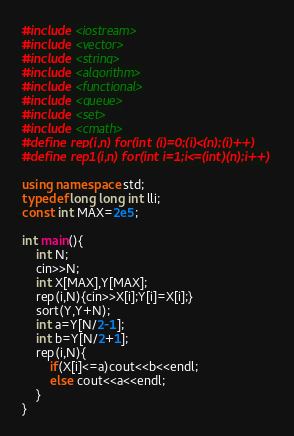Convert code to text. <code><loc_0><loc_0><loc_500><loc_500><_C++_>#include <iostream>
#include <vector>
#include <string>
#include <algorithm>
#include <functional>
#include <queue>
#include <set>
#include <cmath>
#define rep(i,n) for(int (i)=0;(i)<(n);(i)++)
#define rep1(i,n) for(int i=1;i<=(int)(n);i++)

using namespace std;
typedef long long int lli;
const int MAX=2e5;

int main(){
	int N;
	cin>>N;
	int X[MAX],Y[MAX];
	rep(i,N){cin>>X[i];Y[i]=X[i];}
	sort(Y,Y+N);
	int a=Y[N/2-1];
	int b=Y[N/2+1];
	rep(i,N){
		if(X[i]<=a)cout<<b<<endl;
		else cout<<a<<endl;
    }
}</code> 